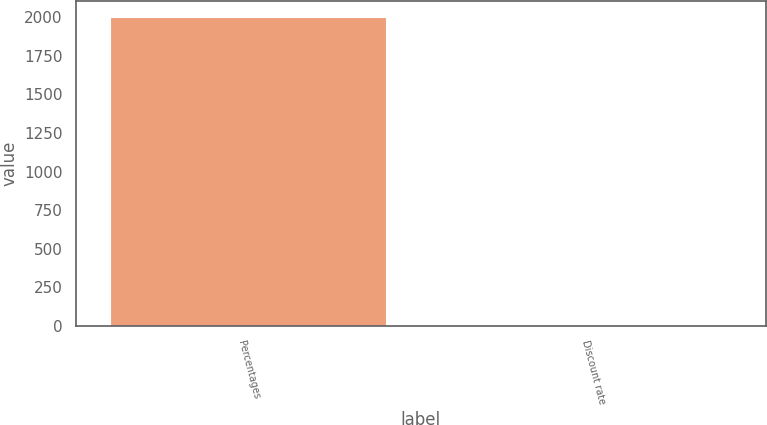<chart> <loc_0><loc_0><loc_500><loc_500><bar_chart><fcel>Percentages<fcel>Discount rate<nl><fcel>2005<fcel>6<nl></chart> 